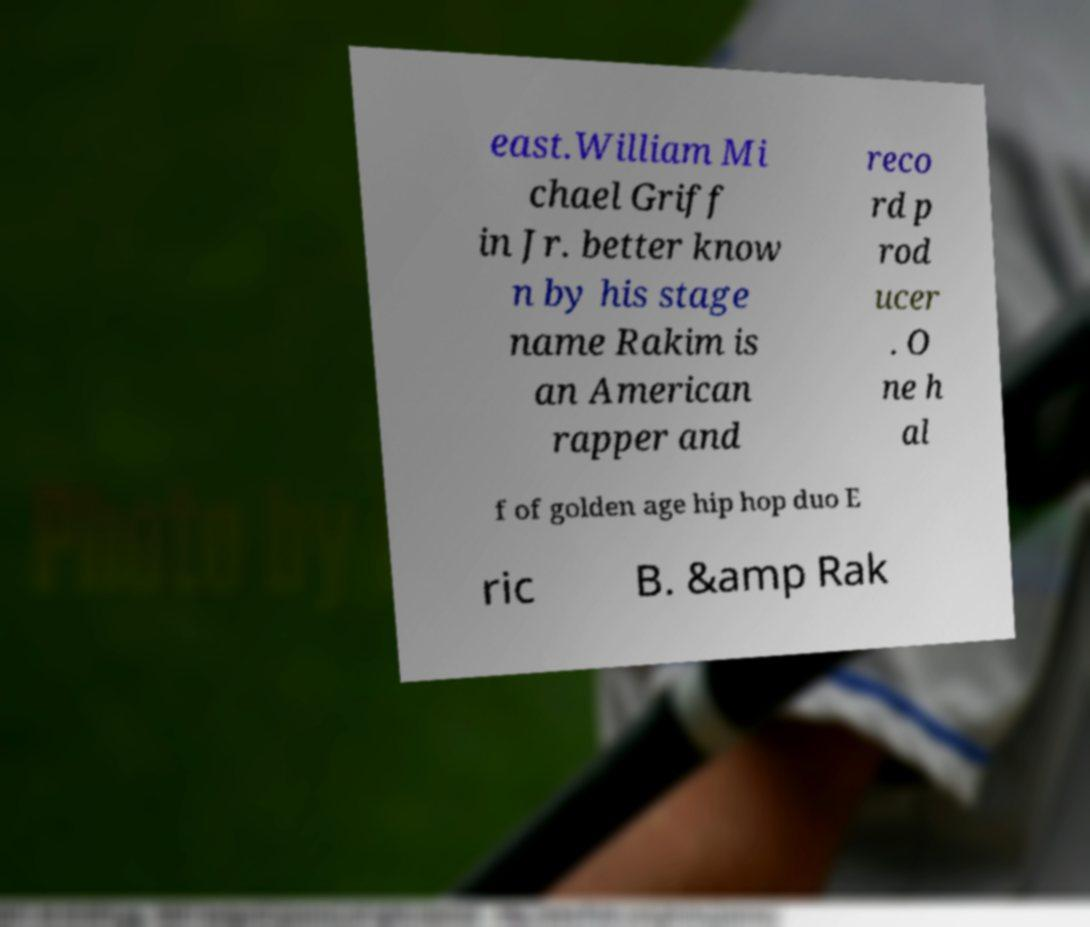Can you accurately transcribe the text from the provided image for me? east.William Mi chael Griff in Jr. better know n by his stage name Rakim is an American rapper and reco rd p rod ucer . O ne h al f of golden age hip hop duo E ric B. &amp Rak 